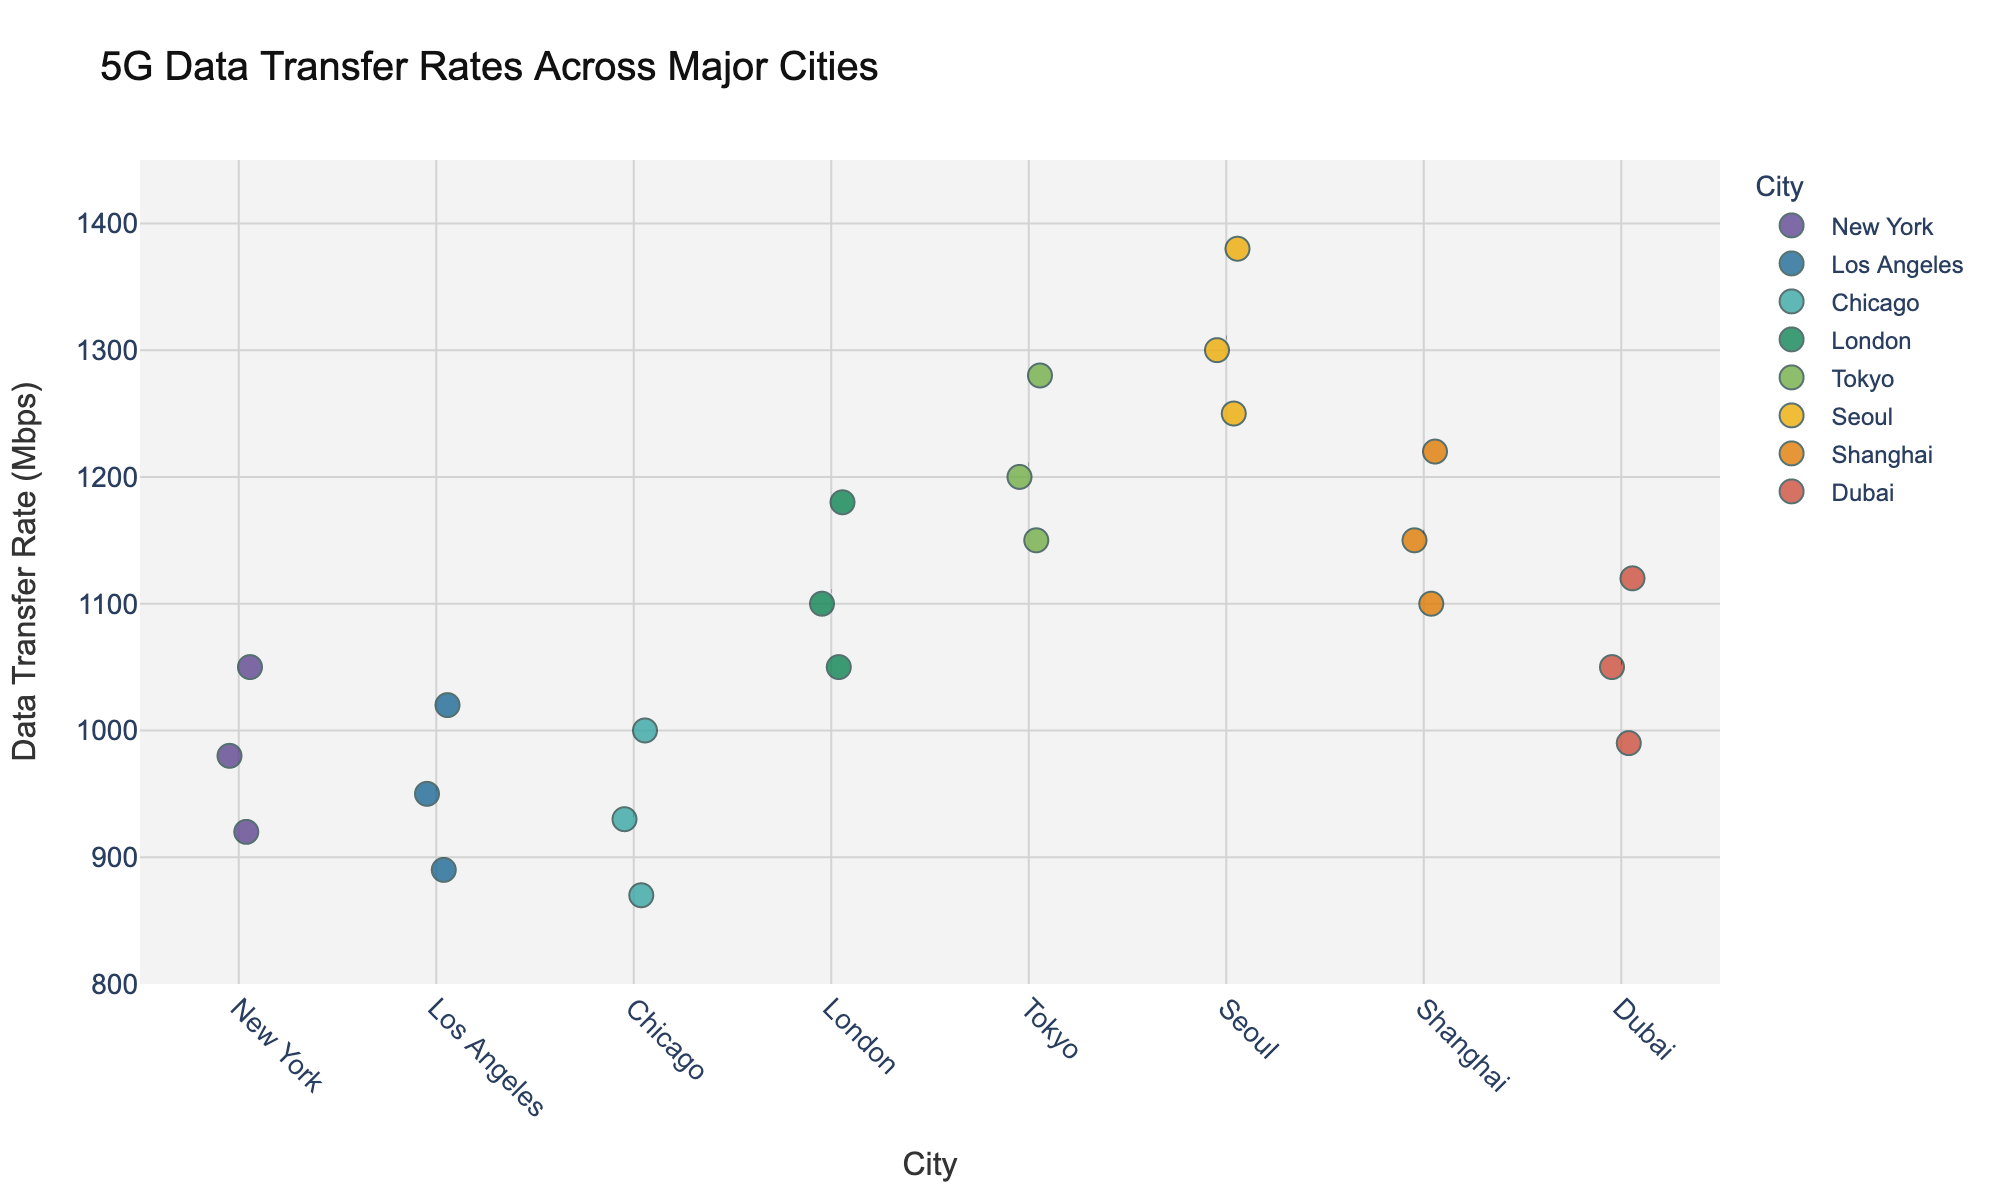What's the title of the plot? The title is typically placed at the top of the plot and is explicitly noticeable.
Answer: 5G Data Transfer Rates Across Major Cities How many cities are represented in the plot? Count the number of unique categories on the x-axis labeled "City".
Answer: 7 What is the highest data transfer rate recorded in Tokyo? Identify the position of Tokyo on the x-axis and observe the uppermost data point in that cluster.
Answer: 1280 Mbps What is the average data transfer rate in Seoul? Locate Seoul on the x-axis and compute the mean of its data points: (1300+1380+1250)/3.
Answer: 1310 Mbps Which city has the lowest minimum data transfer rate shown? Compare the lowest points in all cities by observing where the points fall lowest on the y-axis.
Answer: Chicago (870 Mbps) Of all the cities, which one shows the most consistent data transfer rates? Determine consistency by looking at the spread of data points; the city with the least vertical dispersion in the points is the most consistent.
Answer: New York Which city has the highest average data transfer rate? Visually identify the city with the highest placement of the average line relative to others; the dashed line indicates the average.
Answer: Seoul What is the range of data transfer rates in Shanghai? Find the lowest and highest data points in Shanghai on the y-axis and subtract the lowest from the highest (1220 - 1100).
Answer: 120 Mbps Which cities have data transfer rates that exceed 1200 Mbps? Look for data points that are positioned above the 1200 Mbps mark on the y-axis.
Answer: Tokyo, Seoul Between Chicago and Los Angeles, which city has a higher top data transfer rate? Compare the highest data points in the clusters for Chicago and Los Angeles on the y-axis.
Answer: Los Angeles 